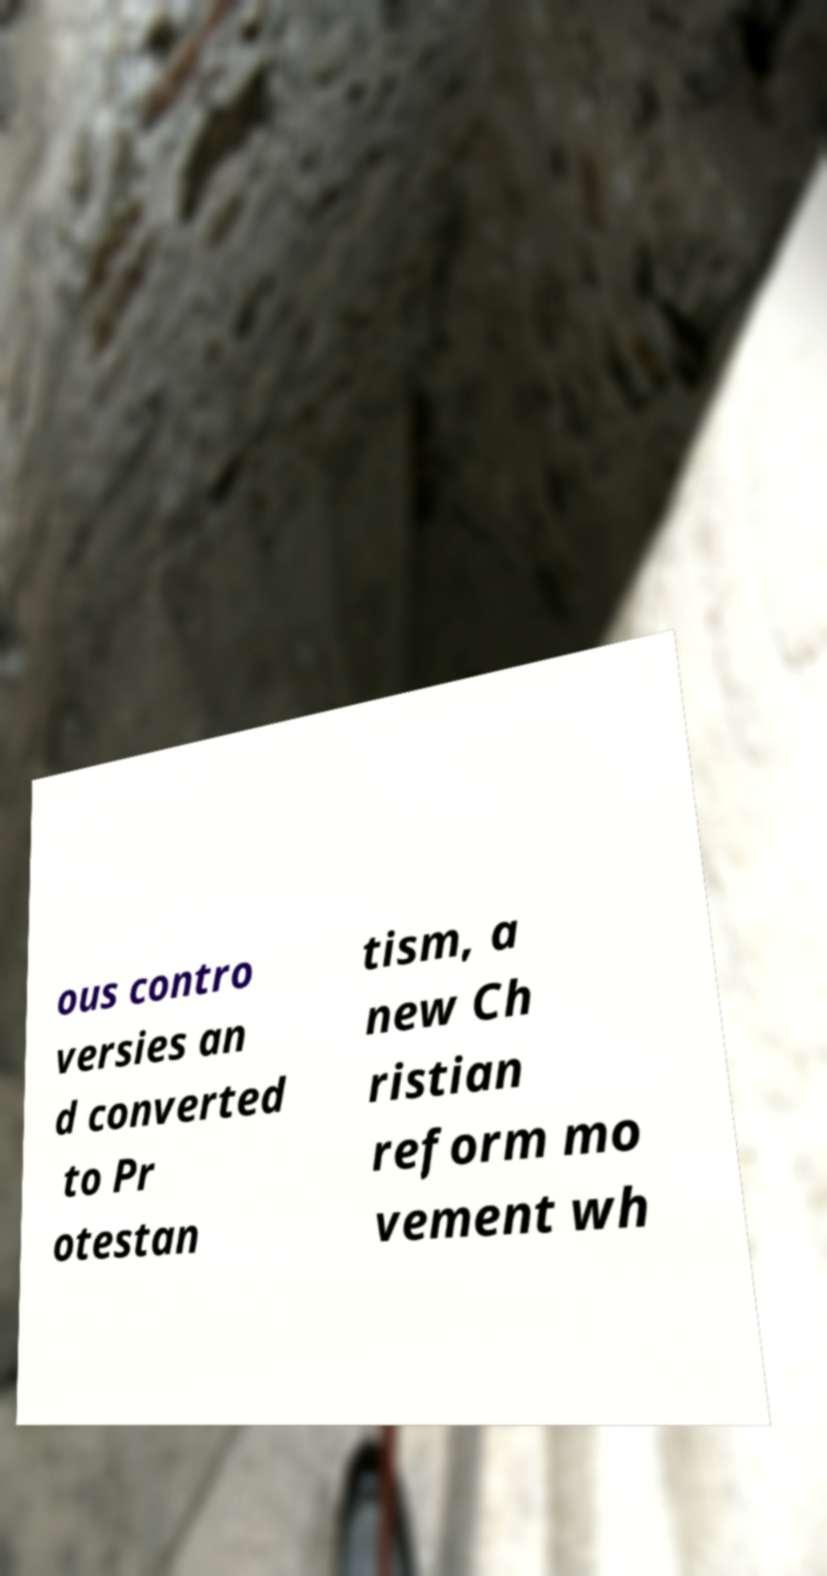Could you assist in decoding the text presented in this image and type it out clearly? ous contro versies an d converted to Pr otestan tism, a new Ch ristian reform mo vement wh 